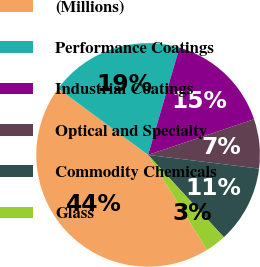Convert chart. <chart><loc_0><loc_0><loc_500><loc_500><pie_chart><fcel>(Millions)<fcel>Performance Coatings<fcel>Industrial Coatings<fcel>Optical and Specialty<fcel>Commodity Chemicals<fcel>Glass<nl><fcel>43.96%<fcel>19.4%<fcel>15.3%<fcel>7.12%<fcel>11.21%<fcel>3.02%<nl></chart> 